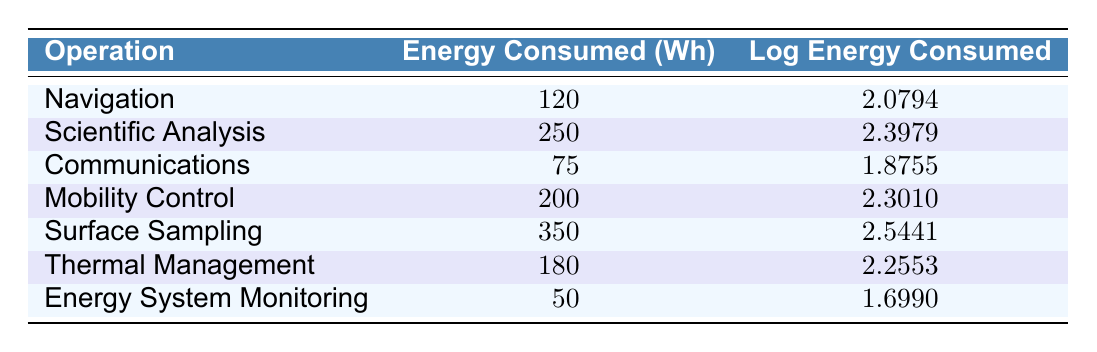What operation consumes the most energy? The operations are listed with their respective energy consumption values. The maximum value is for Surface Sampling, which consumes 350 Wh.
Answer: Surface Sampling What is the energy consumption for Mobility Control? Referring to the table, the value under the Mobility Control operation shows 200 Wh of energy consumed.
Answer: 200 Wh What is the difference in energy consumed between Scientific Analysis and Thermal Management? The energy consumed for Scientific Analysis is 250 Wh and for Thermal Management is 180 Wh. The difference is calculated as 250 - 180 = 70 Wh.
Answer: 70 Wh Is the energy consumed for Communications less than that for Navigation? The energy consumed for Communications is 75 Wh, and for Navigation, it is 120 Wh. Since 75 is less than 120, the statement is true.
Answer: Yes What is the average energy consumed across all operations listed? To find the average, sum all the energy consumed: 120 + 250 + 75 + 200 + 350 + 180 + 50 = 1225 Wh. There are 7 operations, so the average is 1225 / 7 = 175 Wh.
Answer: 175 Wh What operation has a logarithmic energy consumption closest to 2.3? Looking through the log energy values, Mobility Control has a log energy value of 2.3010, which is closest to 2.3.
Answer: Mobility Control Which operation uses the least amount of energy? The values in the table show that the Energy System Monitoring operation has the lowest energy consumption at 50 Wh.
Answer: Energy System Monitoring What is the total energy consumption for Surface Sampling and Thermal Management combined? The energy consumed for Surface Sampling is 350 Wh, and for Thermal Management is 180 Wh. Combining these gives 350 + 180 = 530 Wh.
Answer: 530 Wh Is the energy consumed for Scientific Analysis greater than the combined energy of Navigation and Communications? Navigation consumes 120 Wh and Communications consumes 75 Wh. Their total is 120 + 75 = 195 Wh. Scientific Analysis consumes 250 Wh, which is greater than 195 Wh. Thus, the statement is true.
Answer: Yes 